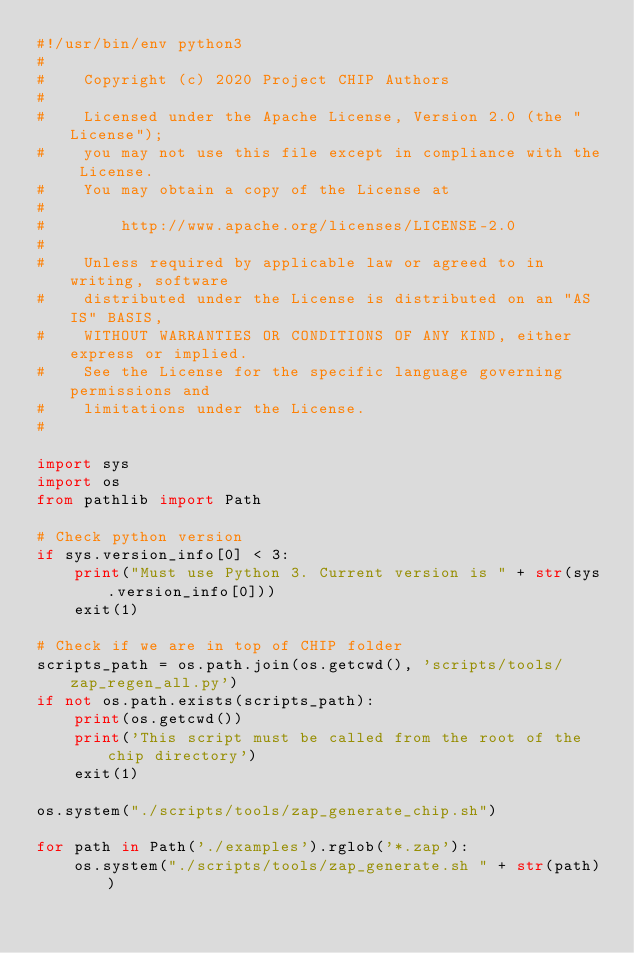<code> <loc_0><loc_0><loc_500><loc_500><_Python_>#!/usr/bin/env python3
#
#    Copyright (c) 2020 Project CHIP Authors
#
#    Licensed under the Apache License, Version 2.0 (the "License");
#    you may not use this file except in compliance with the License.
#    You may obtain a copy of the License at
#
#        http://www.apache.org/licenses/LICENSE-2.0
#
#    Unless required by applicable law or agreed to in writing, software
#    distributed under the License is distributed on an "AS IS" BASIS,
#    WITHOUT WARRANTIES OR CONDITIONS OF ANY KIND, either express or implied.
#    See the License for the specific language governing permissions and
#    limitations under the License.
#

import sys
import os
from pathlib import Path

# Check python version
if sys.version_info[0] < 3:
    print("Must use Python 3. Current version is " + str(sys.version_info[0]))
    exit(1)

# Check if we are in top of CHIP folder
scripts_path = os.path.join(os.getcwd(), 'scripts/tools/zap_regen_all.py')
if not os.path.exists(scripts_path):
    print(os.getcwd())
    print('This script must be called from the root of the chip directory')
    exit(1)

os.system("./scripts/tools/zap_generate_chip.sh")

for path in Path('./examples').rglob('*.zap'):
    os.system("./scripts/tools/zap_generate.sh " + str(path))
</code> 